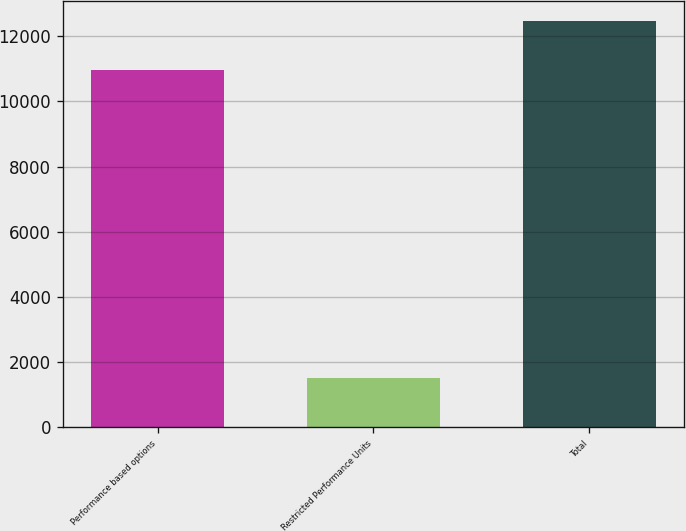Convert chart to OTSL. <chart><loc_0><loc_0><loc_500><loc_500><bar_chart><fcel>Performance based options<fcel>Restricted Performance Units<fcel>Total<nl><fcel>10979<fcel>1494<fcel>12473<nl></chart> 